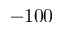<formula> <loc_0><loc_0><loc_500><loc_500>- 1 0 0</formula> 